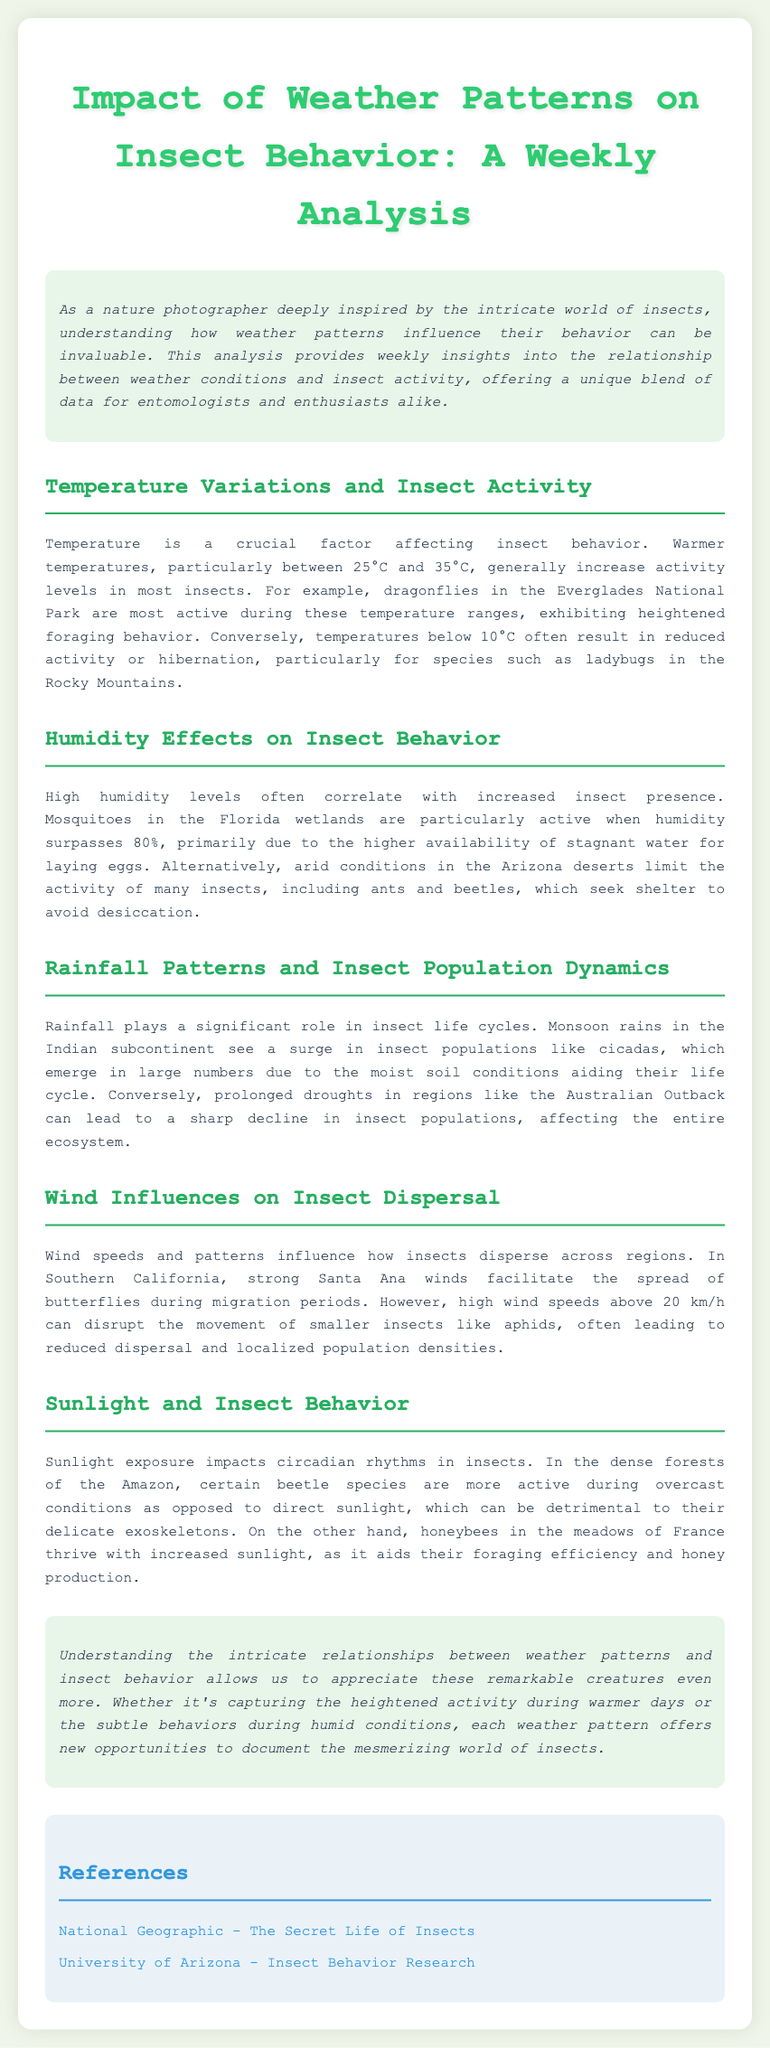What temperature range generally increases insect activity? The document specifies that temperatures between 25°C and 35°C generally increase activity levels in most insects.
Answer: 25°C and 35°C What is the effect of high humidity on mosquitoes according to the document? The document mentions that high humidity levels, particularly above 80%, lead to increased activity of mosquitoes in the Florida wetlands.
Answer: Increased activity Which insect populations surge due to monsoon rains? The document notes that cicadas experience a surge in population during monsoon rains in the Indian subcontinent.
Answer: Cicadas What wind speed disrupts smaller insects like aphids? The document states that high wind speeds above 20 km/h can disrupt the movement of smaller insects like aphids.
Answer: 20 km/h In which location are dragonflies most active? According to the document, dragonflies are most active during the warm temperatures in the Everglades National Park.
Answer: Everglades National Park What behavior do beetles exhibit during overcast conditions in the Amazon? The document explains that certain beetle species are more active during overcast conditions rather than direct sunlight.
Answer: More active What is a factor affecting circadian rhythms in insects? The document identifies sunlight exposure as a significant factor affecting circadian rhythms in insects.
Answer: Sunlight exposure What do strong Santa Ana winds facilitate in Southern California? The document indicates that strong Santa Ana winds facilitate the spread of butterflies during migration periods.
Answer: Spread of butterflies 